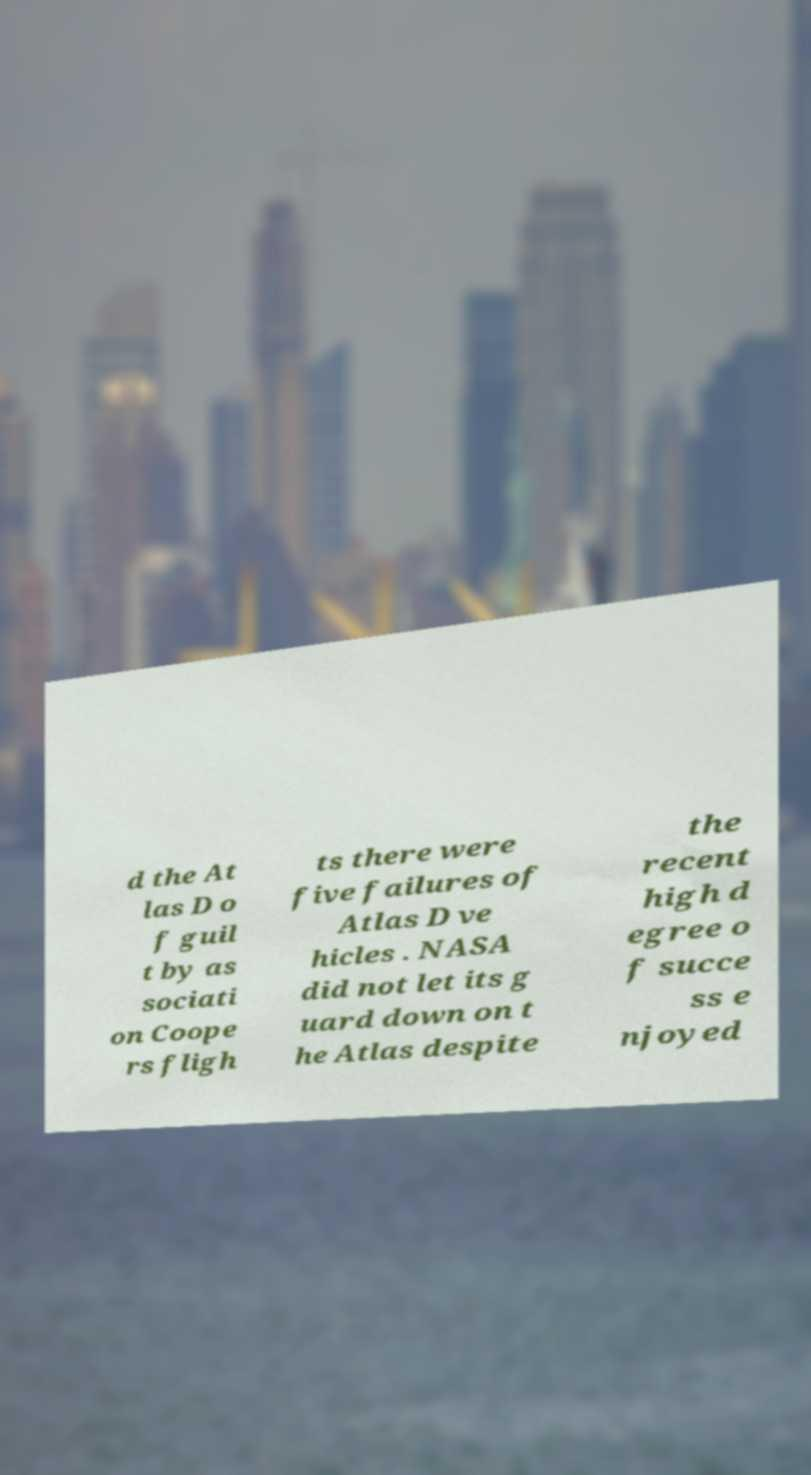Could you assist in decoding the text presented in this image and type it out clearly? d the At las D o f guil t by as sociati on Coope rs fligh ts there were five failures of Atlas D ve hicles . NASA did not let its g uard down on t he Atlas despite the recent high d egree o f succe ss e njoyed 